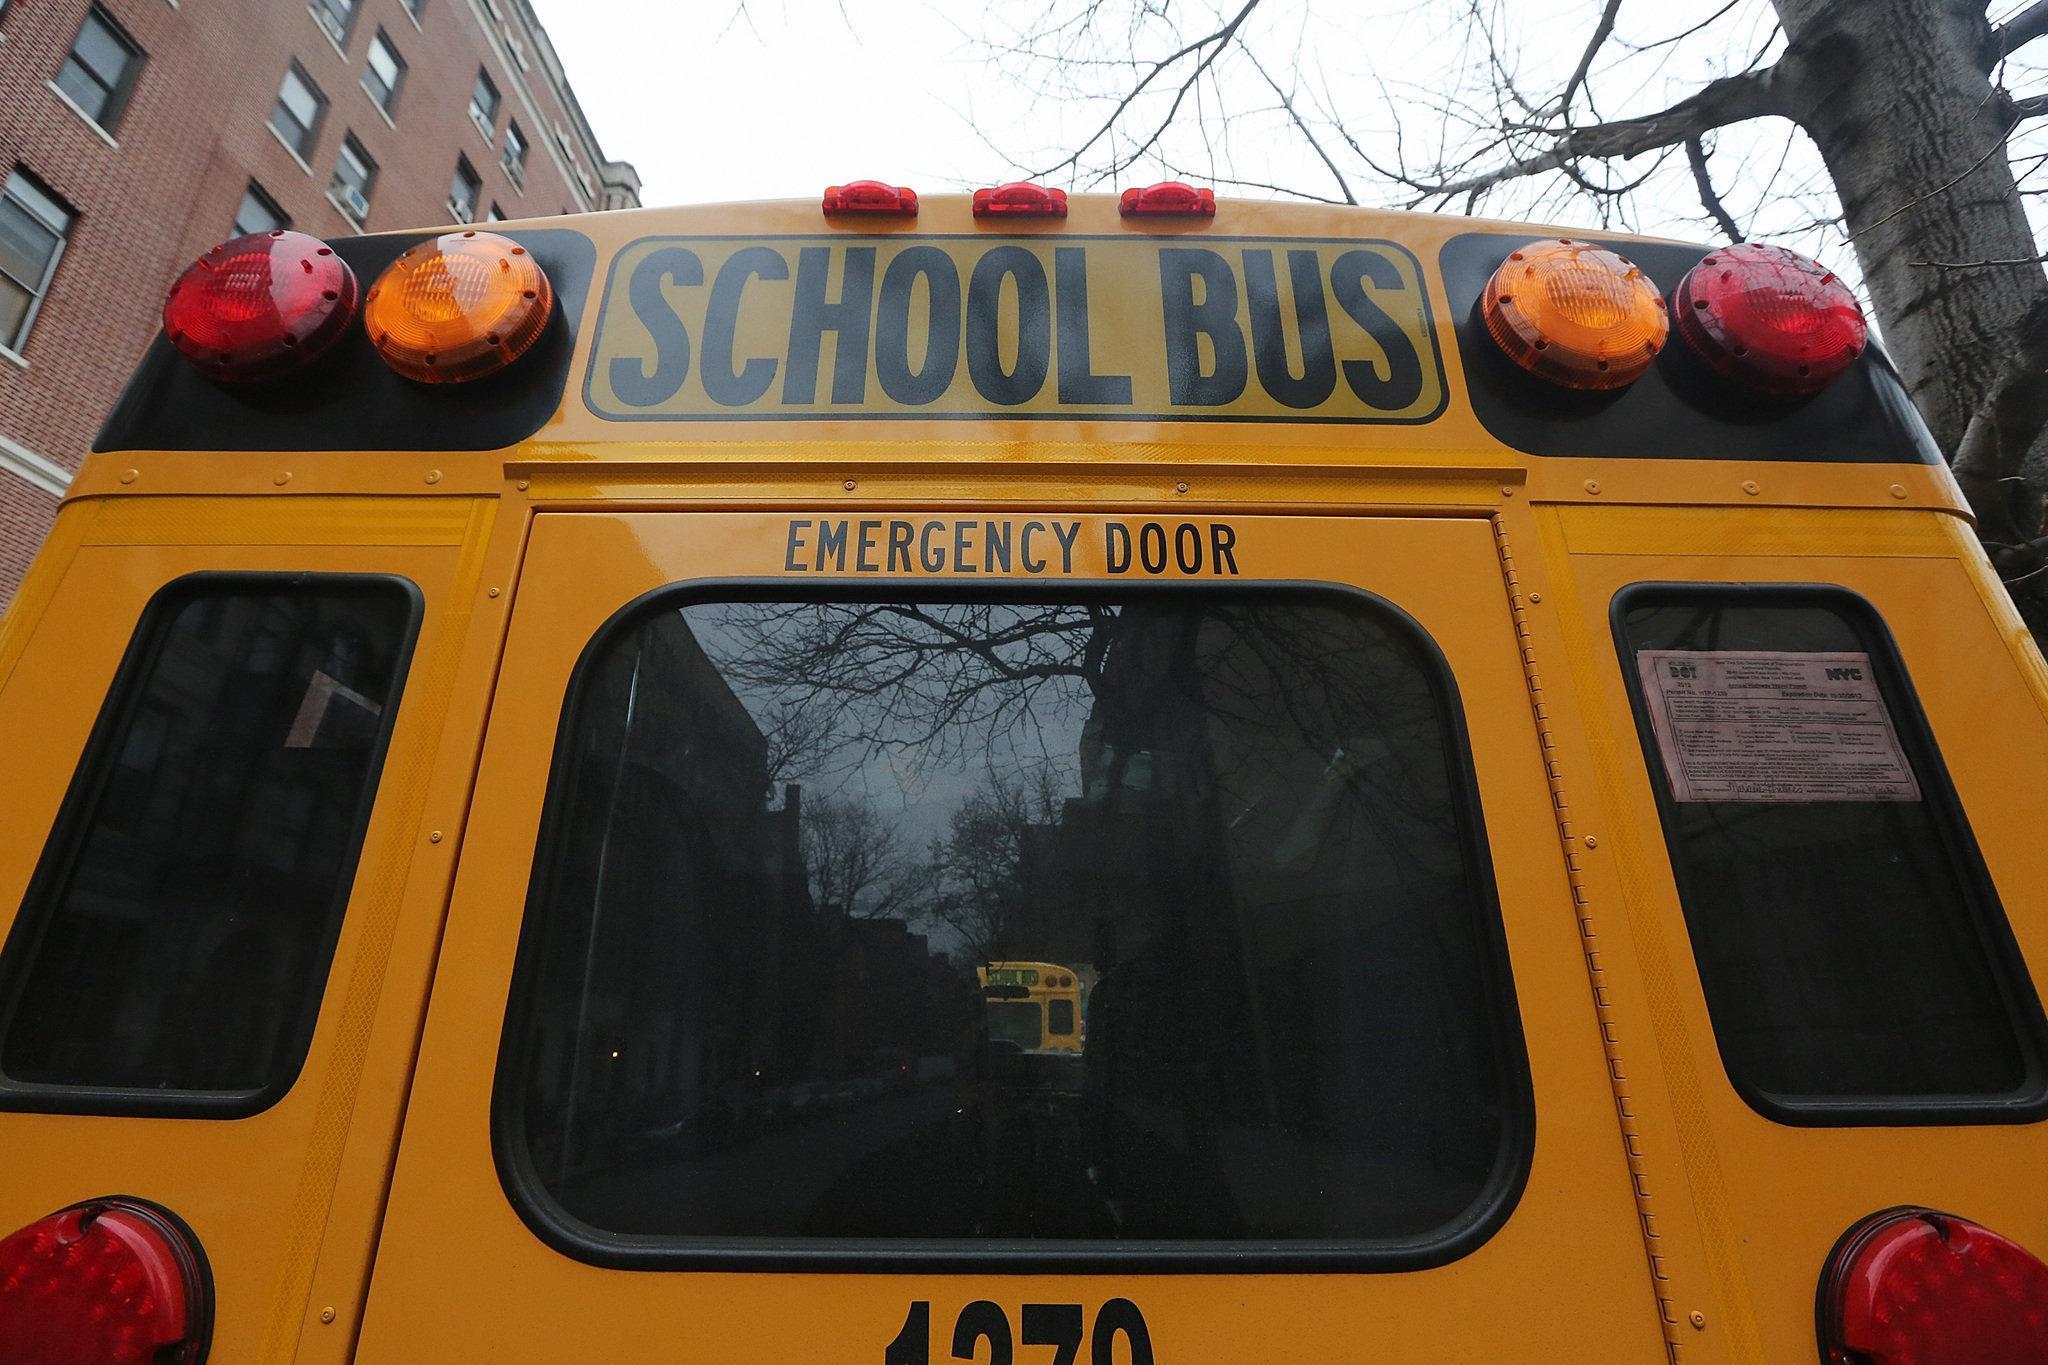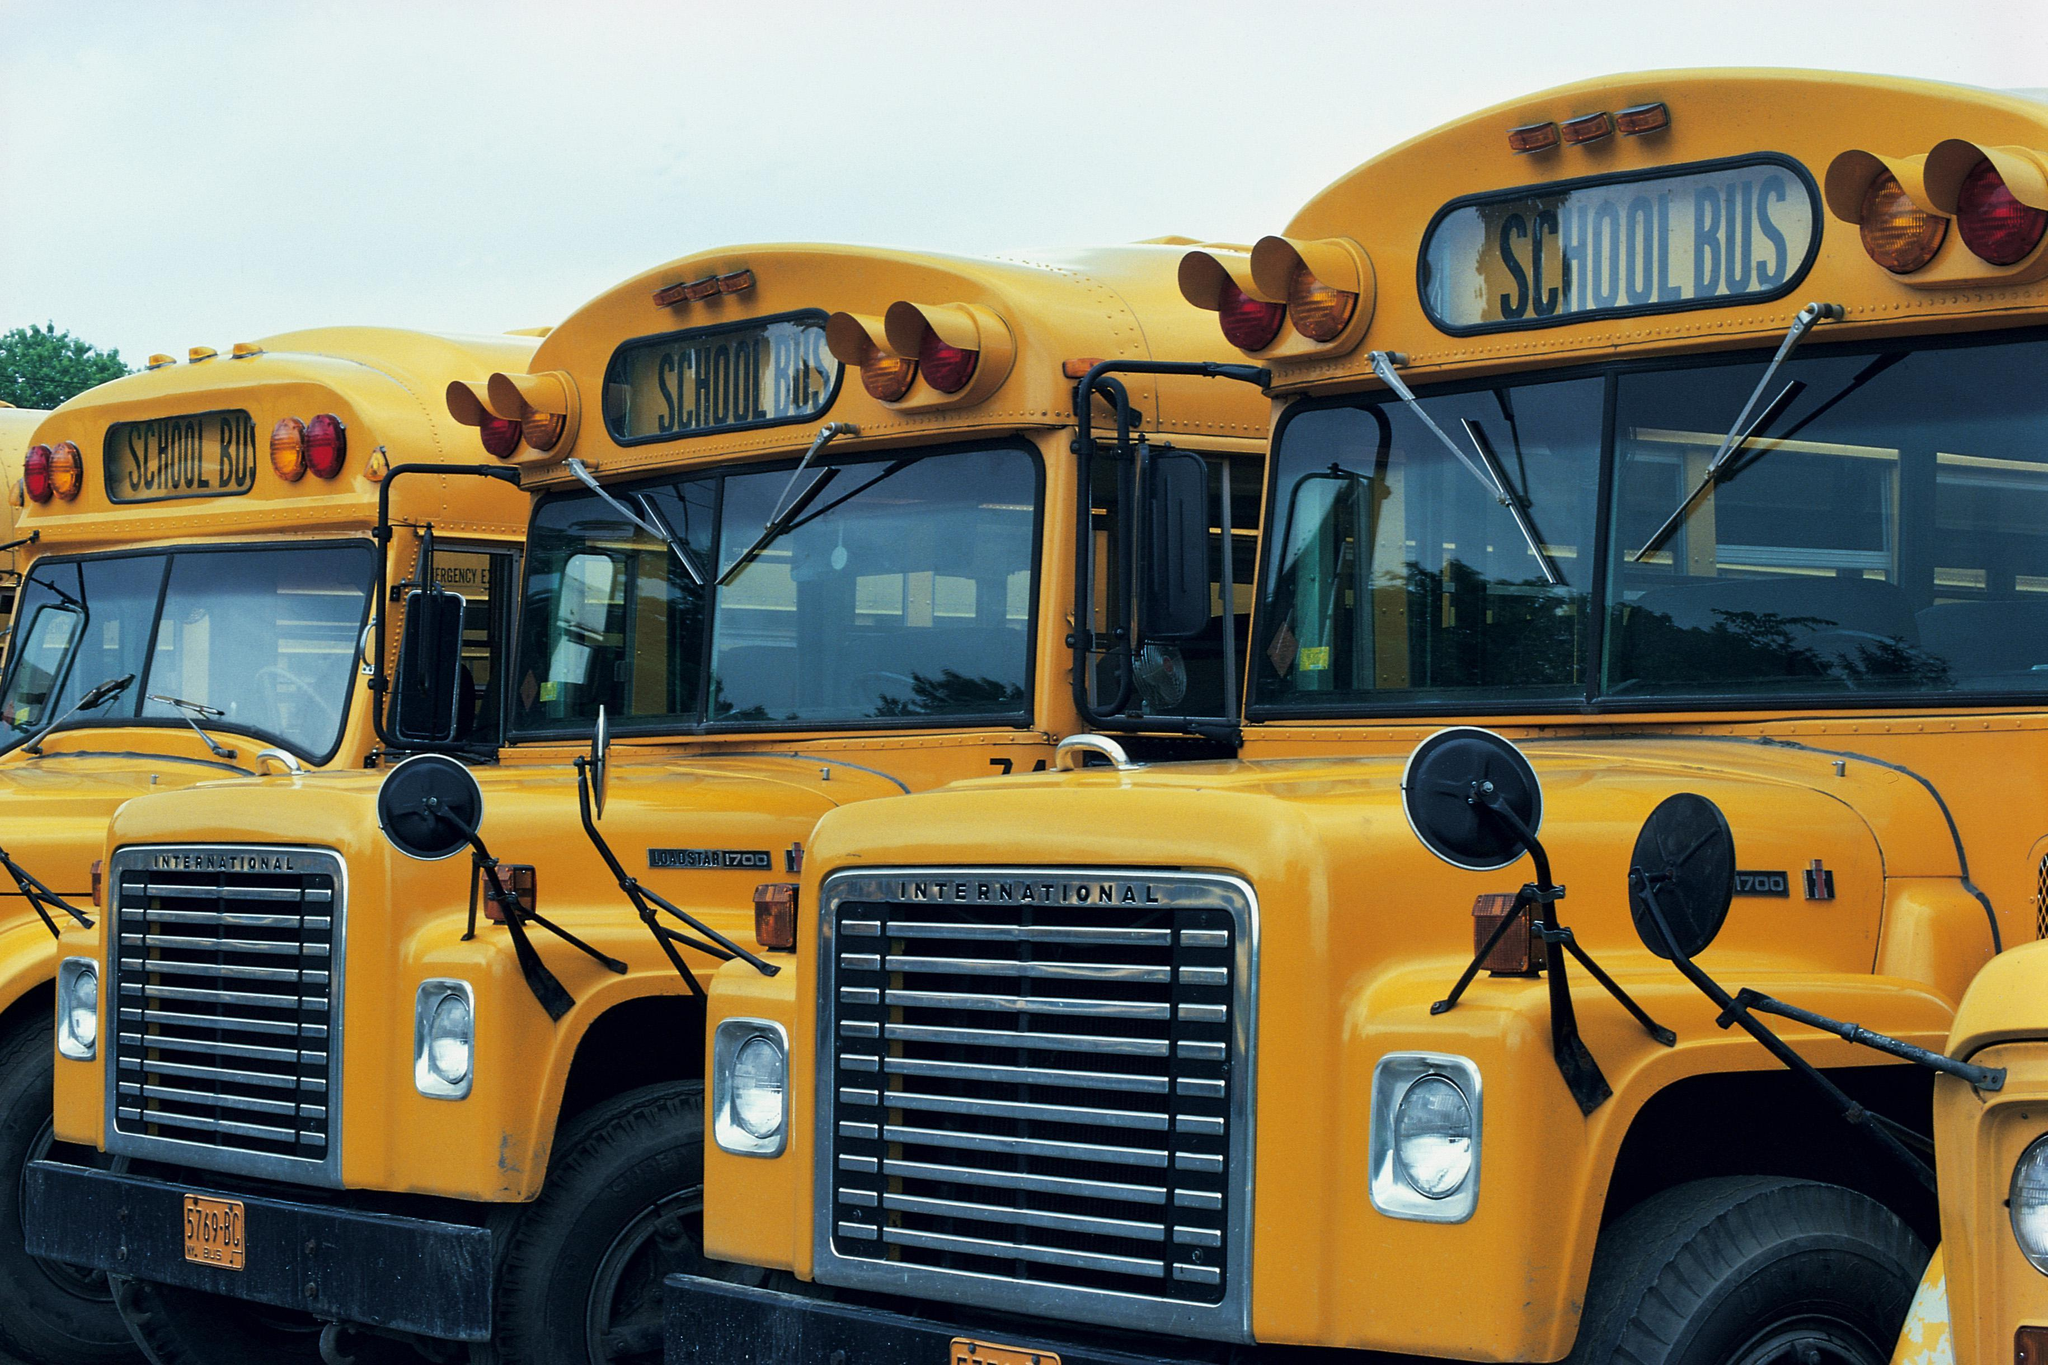The first image is the image on the left, the second image is the image on the right. For the images shown, is this caption "One image in the pair shows a single school bus while the other shows at least three." true? Answer yes or no. Yes. The first image is the image on the left, the second image is the image on the right. Given the left and right images, does the statement "One image shows the rear of a bright yellow school bus, including its emergency door and sets of red and amber lights on the top." hold true? Answer yes or no. Yes. 